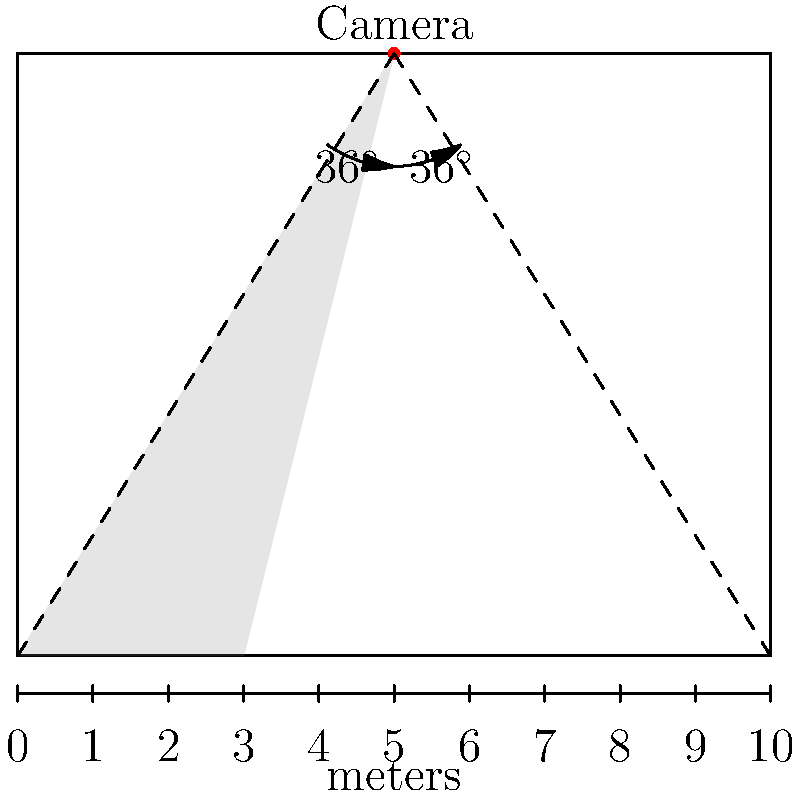In a rectangular room measuring 10m x 8m, a surveillance camera is mounted at the center of one of the 10m walls, 8m above the floor. The camera has a horizontal field of view of 72°. What is the width of the blind spot at floor level directly beneath the camera? To solve this problem, we'll follow these steps:

1) The camera's field of view forms two right triangles. We'll focus on one of these triangles.

2) In this right triangle:
   - The hypotenuse is the line from the camera to the floor corner.
   - The adjacent side to the angle we know is the room's length (8m).
   - The opposite side is half the room's width (5m).

3) The angle between the camera's central line of sight and the edge of its field of view is half of 72°, which is 36°.

4) We can use the tangent function to find the width of half the blind spot:

   $\tan(36°) = \frac{\text{opposite}}{\text{adjacent}} = \frac{x}{8}$

   Where $x$ is half the width of the blind spot.

5) Solving for $x$:

   $x = 8 \tan(36°) \approx 5.78m$

6) Since this is half the blind spot, we double it to get the full width:

   $\text{Full width} = 2x \approx 2(5.78) = 11.56m$

7) However, the room is only 10m wide, so the blind spot extends across the entire width of the room.

Therefore, the width of the blind spot at floor level is 10m, which is the full width of the room.
Answer: 10m 